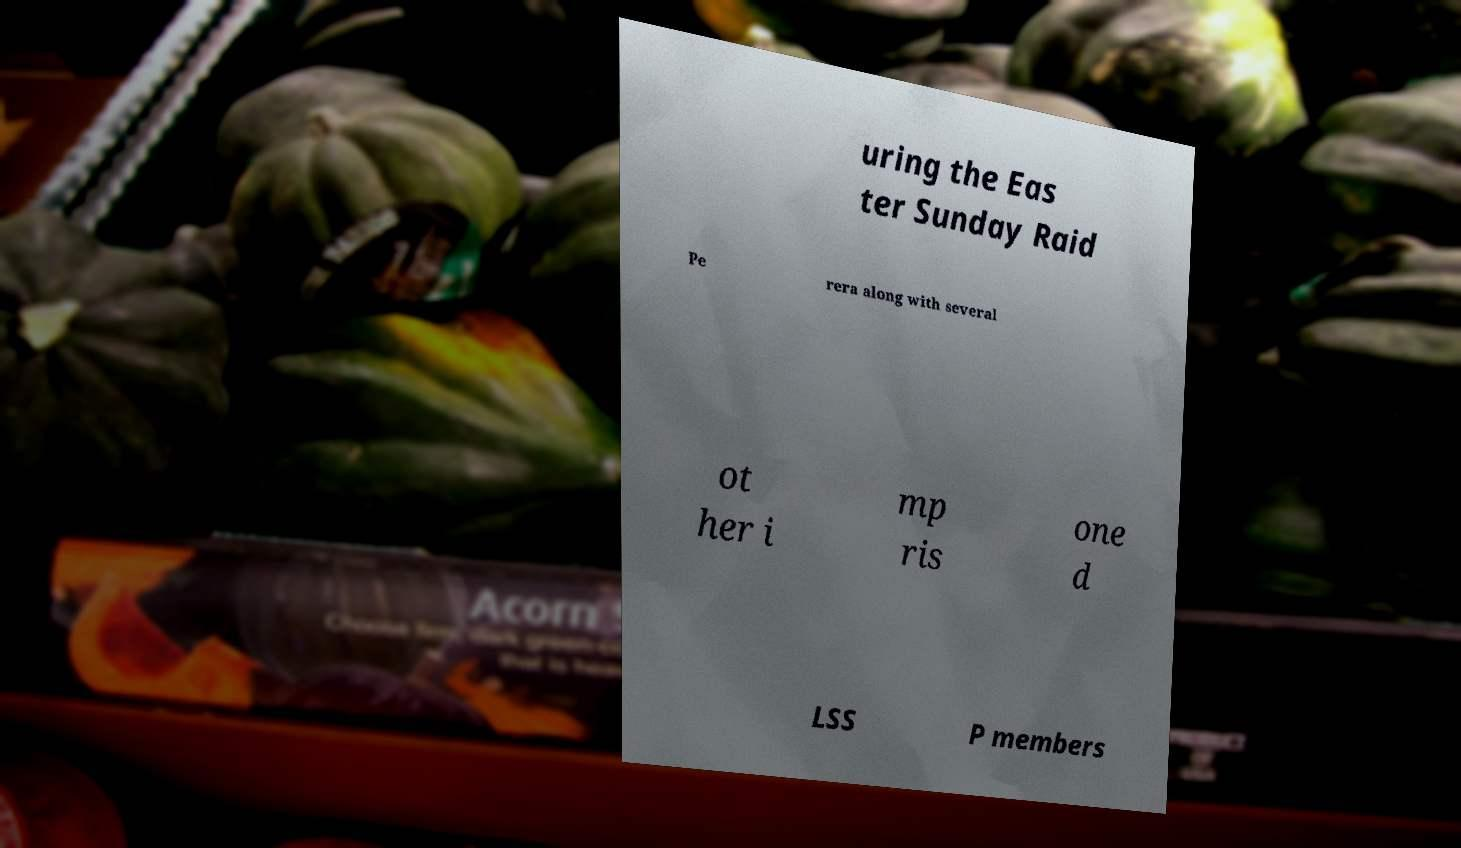Could you extract and type out the text from this image? uring the Eas ter Sunday Raid Pe rera along with several ot her i mp ris one d LSS P members 